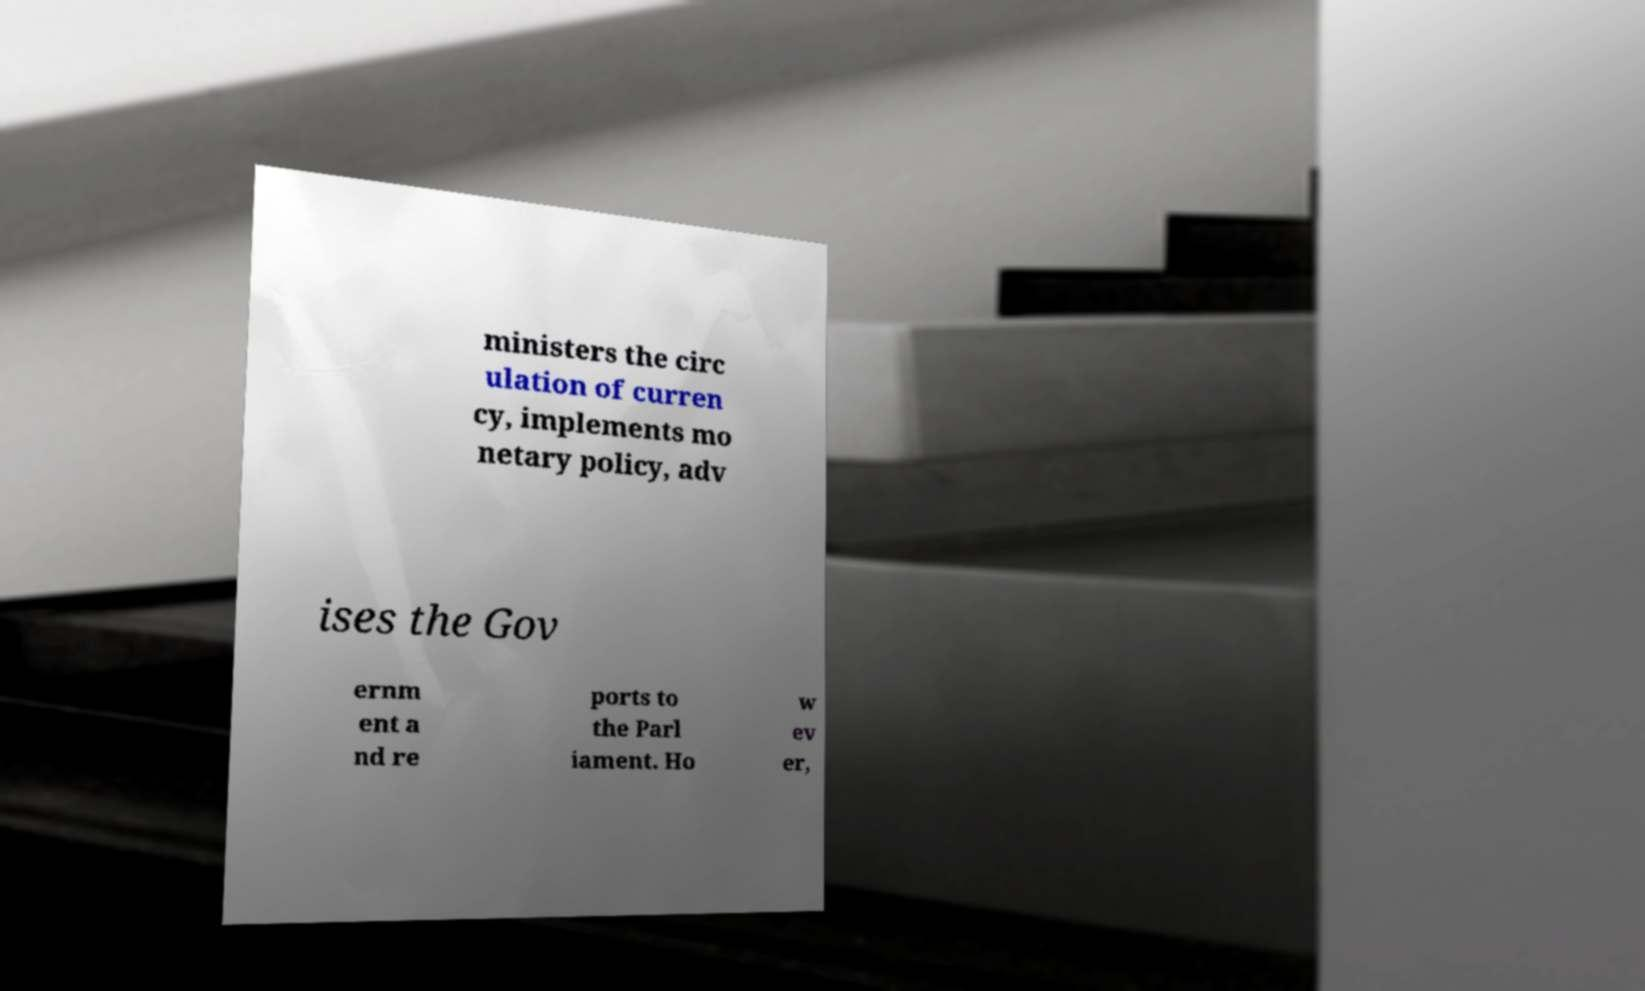Could you assist in decoding the text presented in this image and type it out clearly? ministers the circ ulation of curren cy, implements mo netary policy, adv ises the Gov ernm ent a nd re ports to the Parl iament. Ho w ev er, 